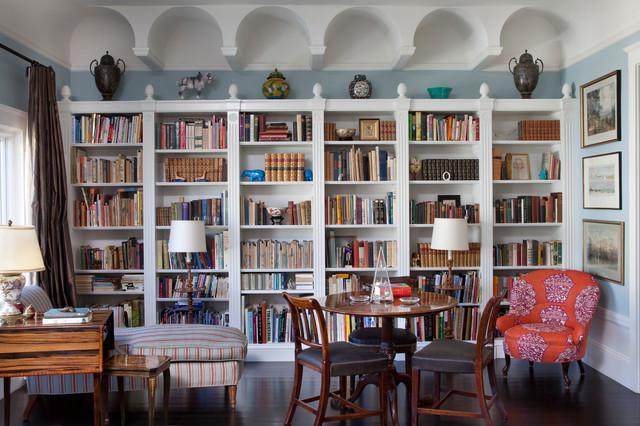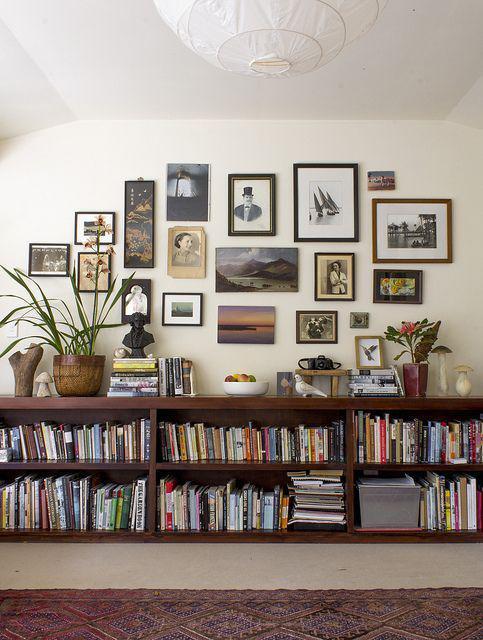The first image is the image on the left, the second image is the image on the right. Examine the images to the left and right. Is the description "In one image, floor to ceiling bookshelves are on both sides of a central fireplace with decor filling the space above." accurate? Answer yes or no. No. The first image is the image on the left, the second image is the image on the right. Evaluate the accuracy of this statement regarding the images: "A room includes a beige sofa near a fireplace flanked by white built-in bookshelves, with something rectangular over the fireplace.". Is it true? Answer yes or no. No. 